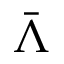Convert formula to latex. <formula><loc_0><loc_0><loc_500><loc_500>\bar { \Lambda }</formula> 